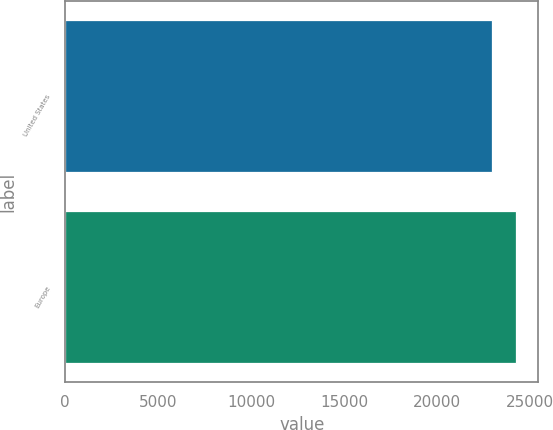Convert chart to OTSL. <chart><loc_0><loc_0><loc_500><loc_500><bar_chart><fcel>United States<fcel>Europe<nl><fcel>22929<fcel>24235<nl></chart> 